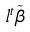<formula> <loc_0><loc_0><loc_500><loc_500>l ^ { t } \tilde { \beta }</formula> 